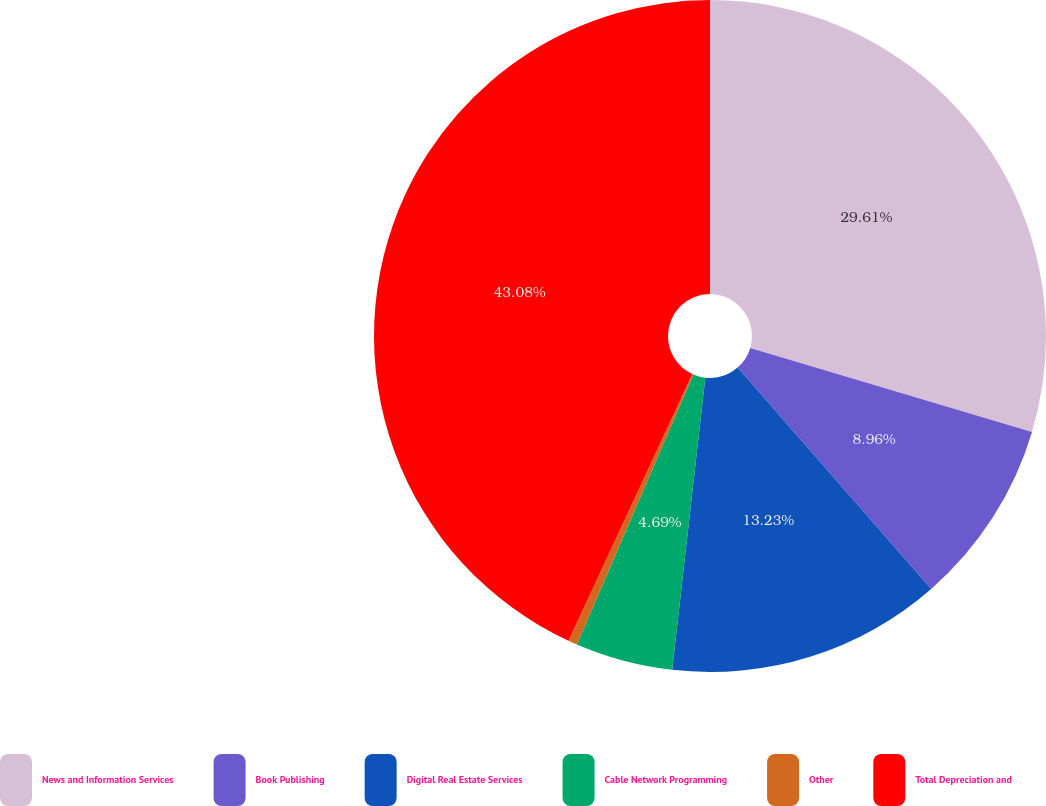Convert chart to OTSL. <chart><loc_0><loc_0><loc_500><loc_500><pie_chart><fcel>News and Information Services<fcel>Book Publishing<fcel>Digital Real Estate Services<fcel>Cable Network Programming<fcel>Other<fcel>Total Depreciation and<nl><fcel>29.61%<fcel>8.96%<fcel>13.23%<fcel>4.69%<fcel>0.43%<fcel>43.09%<nl></chart> 